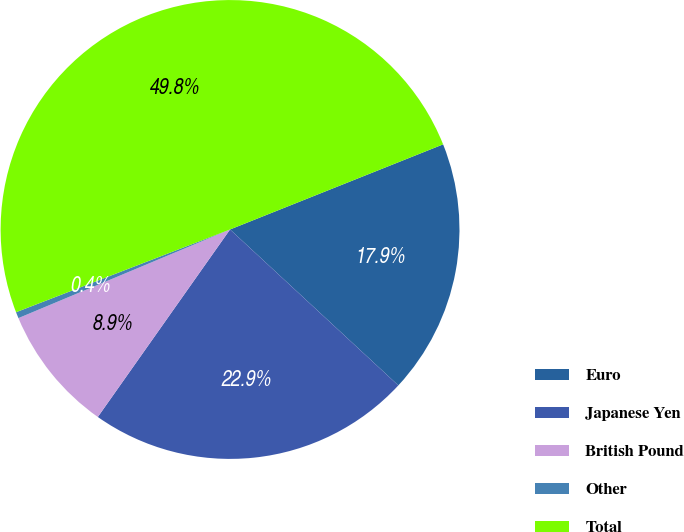<chart> <loc_0><loc_0><loc_500><loc_500><pie_chart><fcel>Euro<fcel>Japanese Yen<fcel>British Pound<fcel>Other<fcel>Total<nl><fcel>17.94%<fcel>22.88%<fcel>8.91%<fcel>0.44%<fcel>49.82%<nl></chart> 